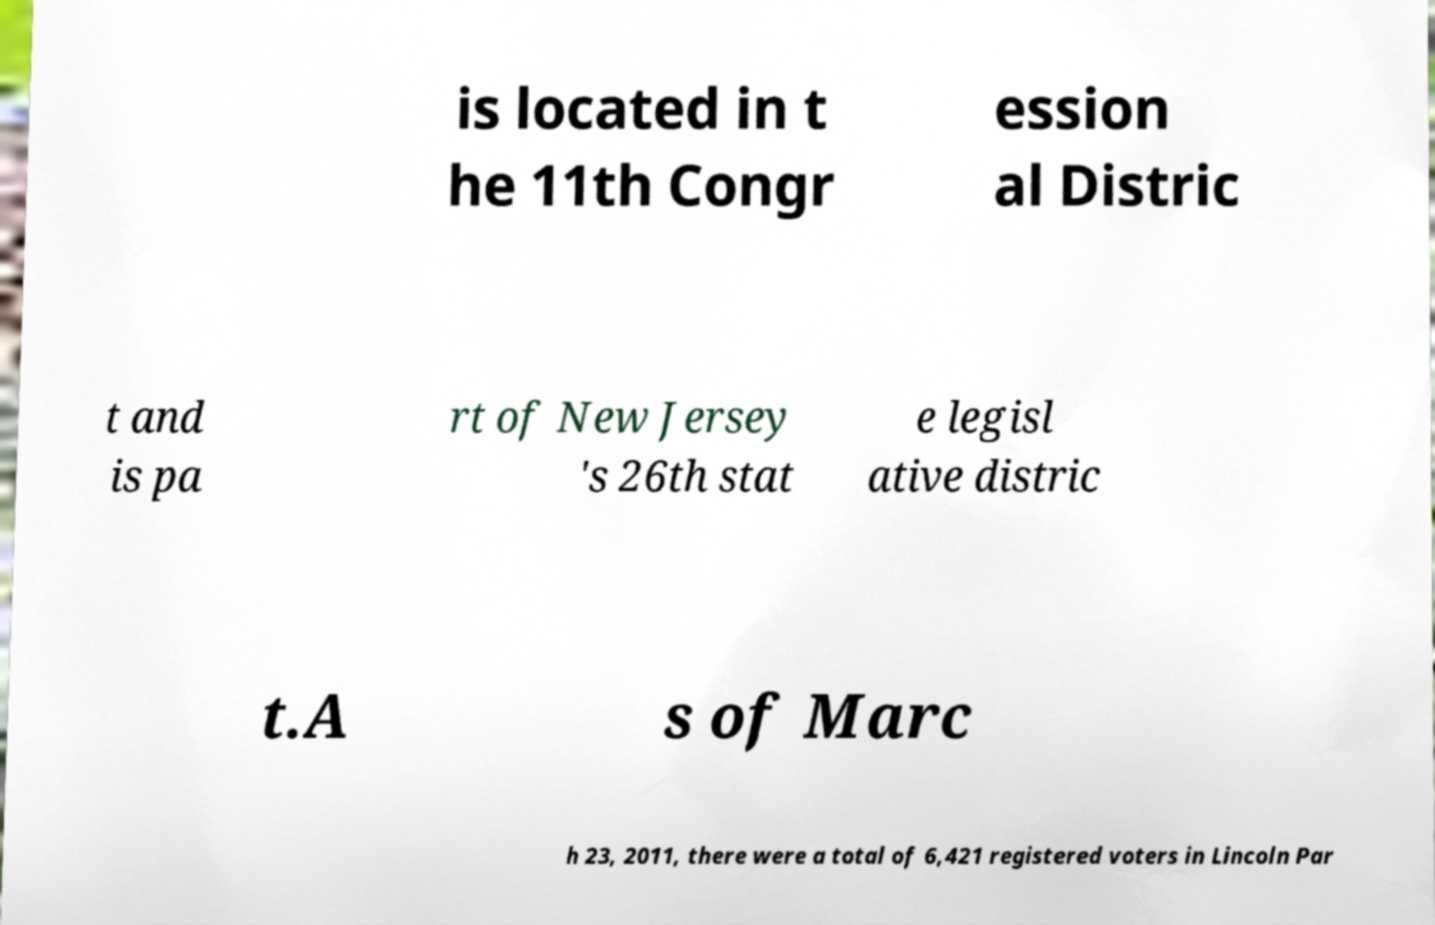What messages or text are displayed in this image? I need them in a readable, typed format. is located in t he 11th Congr ession al Distric t and is pa rt of New Jersey 's 26th stat e legisl ative distric t.A s of Marc h 23, 2011, there were a total of 6,421 registered voters in Lincoln Par 